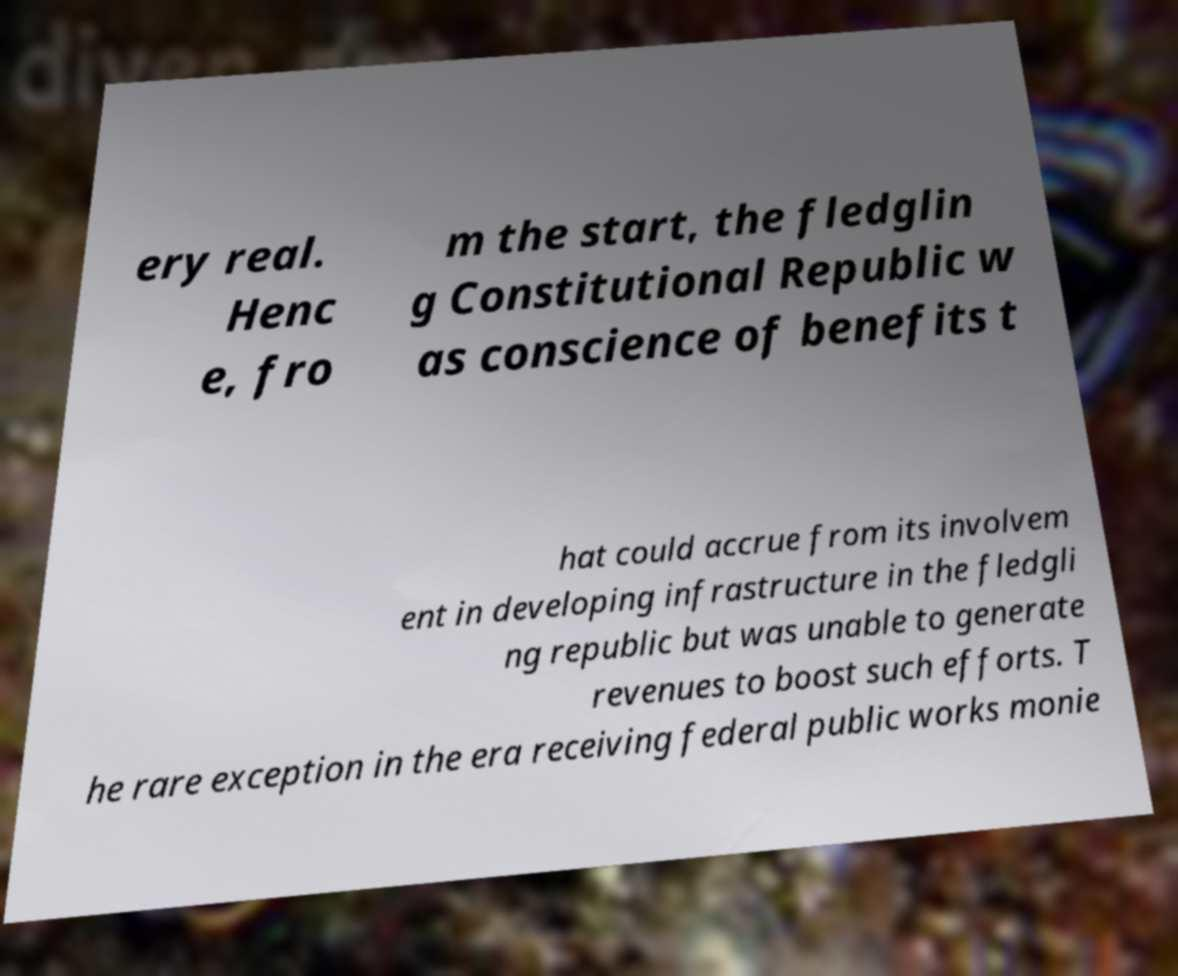Please read and relay the text visible in this image. What does it say? ery real. Henc e, fro m the start, the fledglin g Constitutional Republic w as conscience of benefits t hat could accrue from its involvem ent in developing infrastructure in the fledgli ng republic but was unable to generate revenues to boost such efforts. T he rare exception in the era receiving federal public works monie 